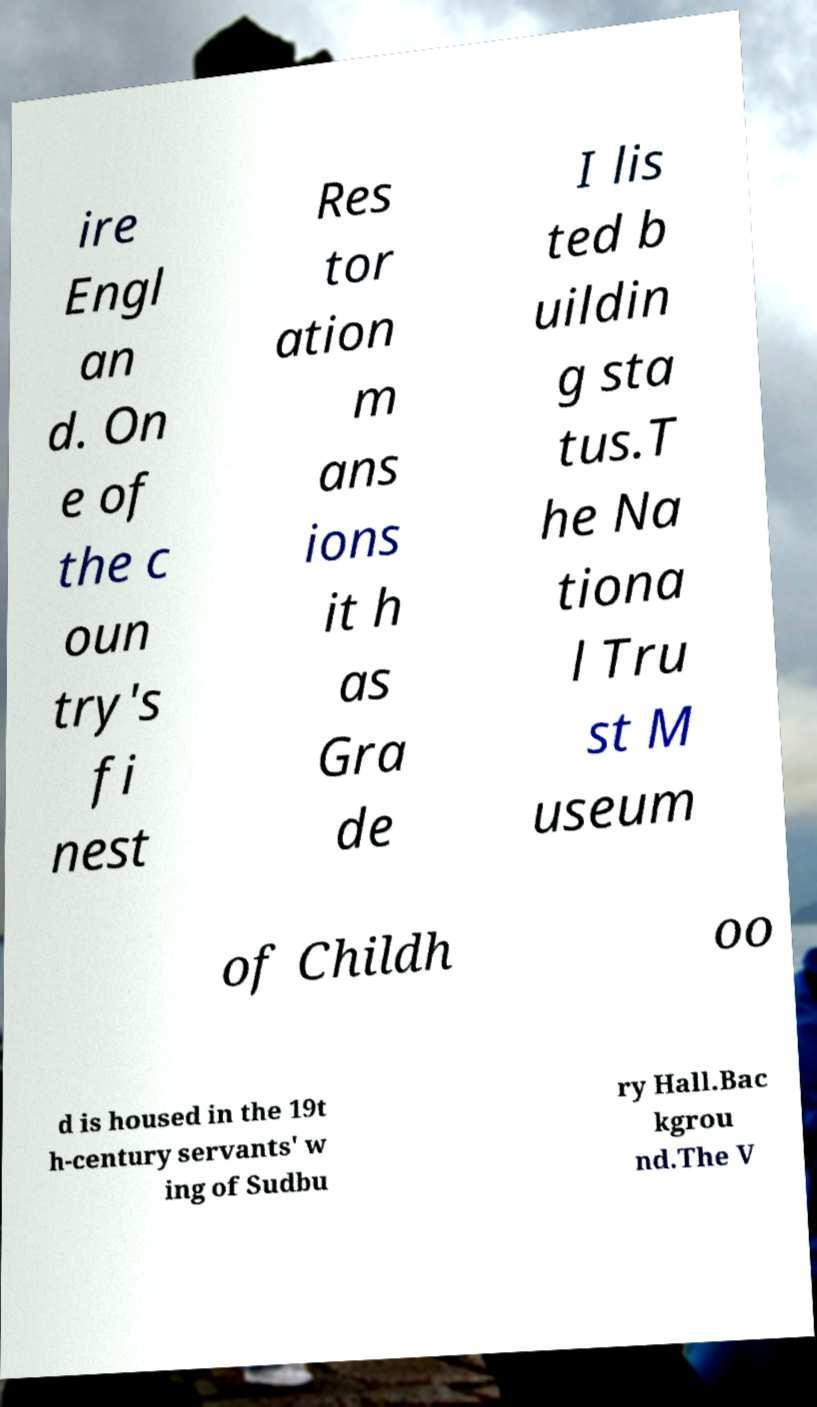Can you accurately transcribe the text from the provided image for me? ire Engl an d. On e of the c oun try's fi nest Res tor ation m ans ions it h as Gra de I lis ted b uildin g sta tus.T he Na tiona l Tru st M useum of Childh oo d is housed in the 19t h-century servants' w ing of Sudbu ry Hall.Bac kgrou nd.The V 